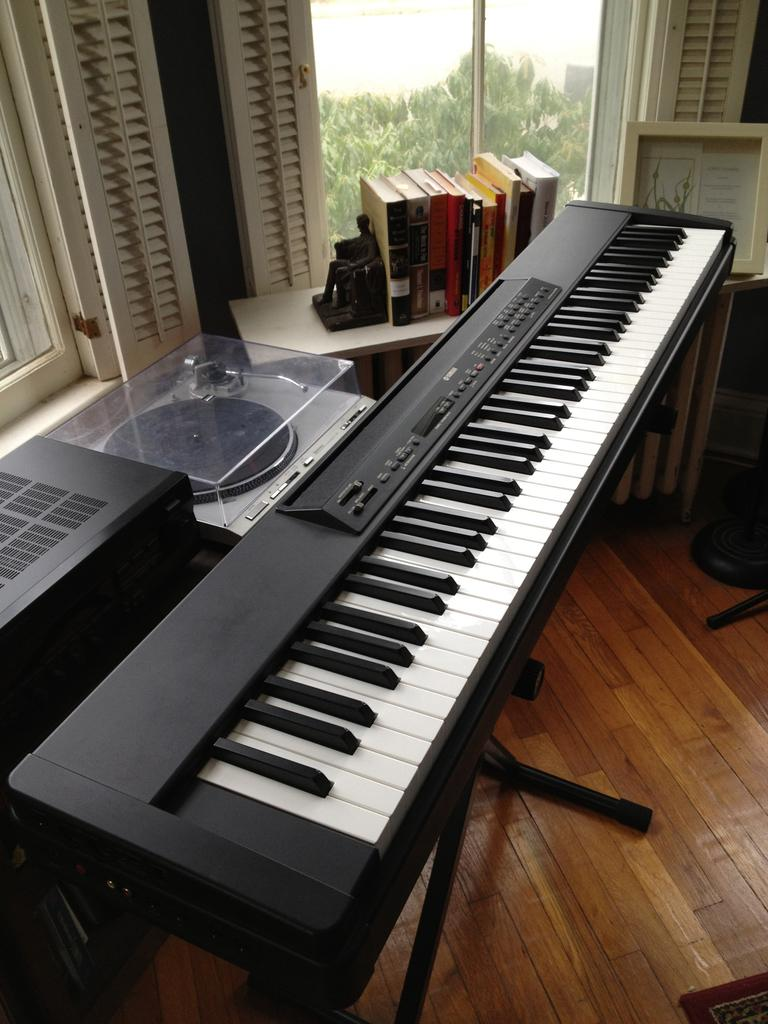What musical instrument is in the image? There is a piano in the image. What can be seen on the left side of the image? There are devices on the left side of the image. What is located in the background of the image? There are objects on a table and windows visible in the background of the image. What is outside the windows in the image? Trees are present outside the windows. What type of advertisement can be seen on the piano in the image? There is no advertisement present on the piano in the image. What kind of fish can be seen swimming in the background of the image? There are no fish visible in the image; it features a piano, devices, objects on a table, windows, and trees outside the windows. 